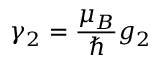<formula> <loc_0><loc_0><loc_500><loc_500>\gamma _ { 2 } = \frac { \mu _ { B } } { } g _ { 2 }</formula> 